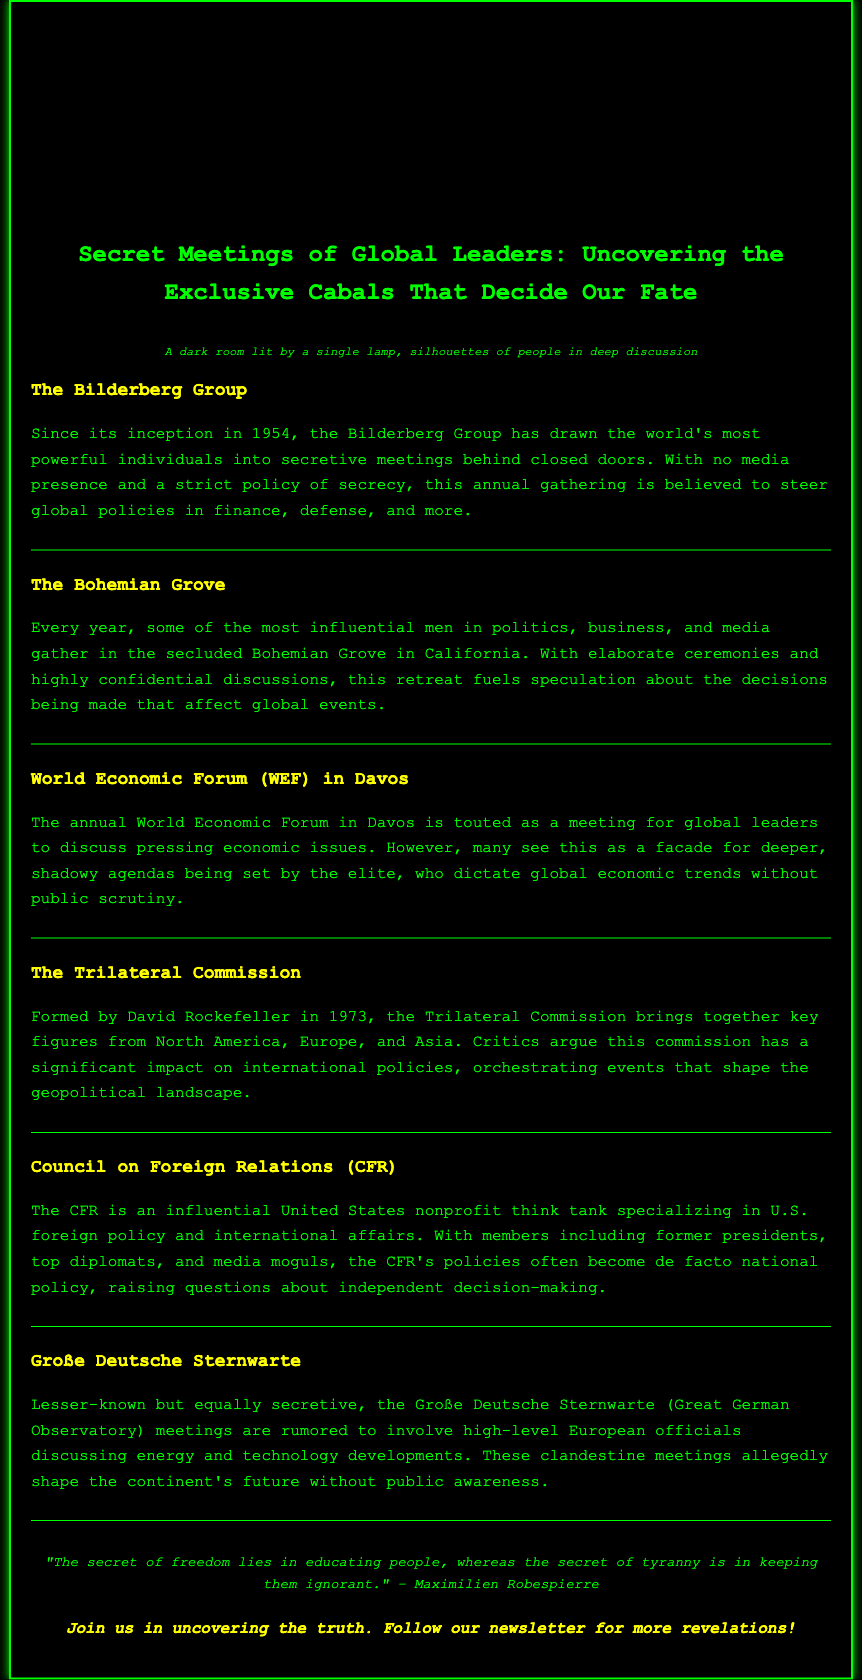What year was the Bilderberg Group founded? The document states that the Bilderberg Group has been in existence since its inception in 1954.
Answer: 1954 Who formed the Trilateral Commission? According to the document, the Trilateral Commission was formed by David Rockefeller in 1973.
Answer: David Rockefeller What is the primary focus of the Council on Foreign Relations? The document describes the CFR as specializing in U.S. foreign policy and international affairs.
Answer: U.S. foreign policy Where does the World Economic Forum take place? The document mentions that the World Economic Forum occurs in Davos.
Answer: Davos What type of individuals gather at the Bohemian Grove? According to the document, influential men in politics, business, and media gather at the Bohemian Grove.
Answer: Influential men What does the Große Deutsche Sternwarte meetings discuss? The document suggests that these meetings involve discussions about energy and technology developments.
Answer: Energy and technology How many major groups are highlighted in the document? The document includes six distinct groups involved in secretive meetings.
Answer: Six What is the visual representation used in the header? The header features an image depicting a dark room lit by a single lamp.
Answer: Dark room lit by a single lamp 